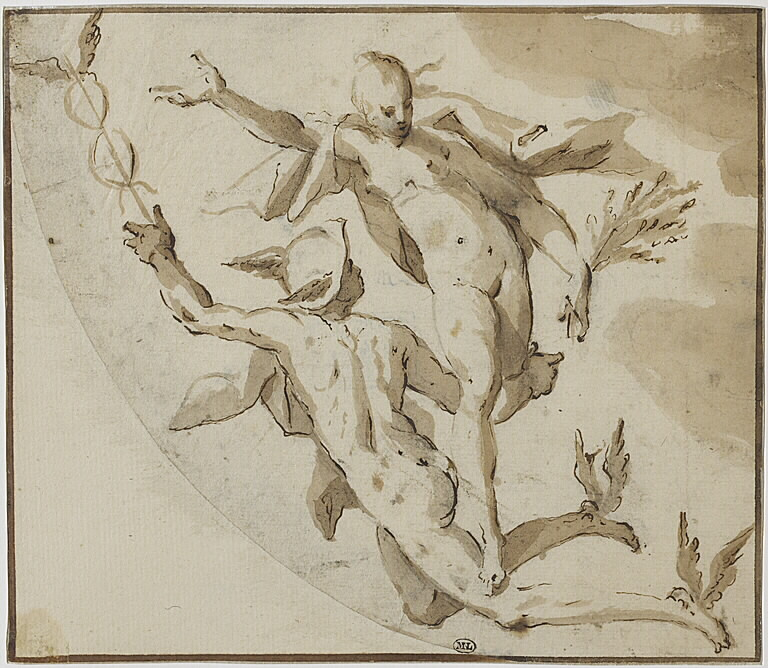What emotions or themes do you think the artist is conveying through this artwork? The artist seems to be conveying themes of energy, movement, and perhaps even a sense of freedom or transcendence. The dynamic pose of the male figure lifting the female figure suggests a narrative of support or rescue. The lightness of the female figure and the flowing lines evoke feelings of grace and delicacy. Overall, the scene elicits an emotional response that combines power with elegance, emphasizing the interplay between strength and beauty. 